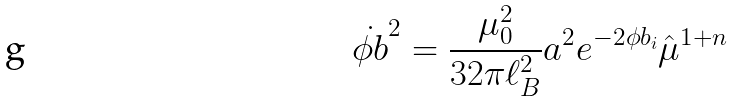Convert formula to latex. <formula><loc_0><loc_0><loc_500><loc_500>\dot { \phi b } ^ { 2 } = \frac { \mu _ { 0 } ^ { 2 } } { 3 2 \pi \ell _ { B } ^ { 2 } } a ^ { 2 } e ^ { - 2 \phi b _ { i } } \hat { \mu } ^ { 1 + n }</formula> 